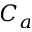<formula> <loc_0><loc_0><loc_500><loc_500>C _ { a }</formula> 